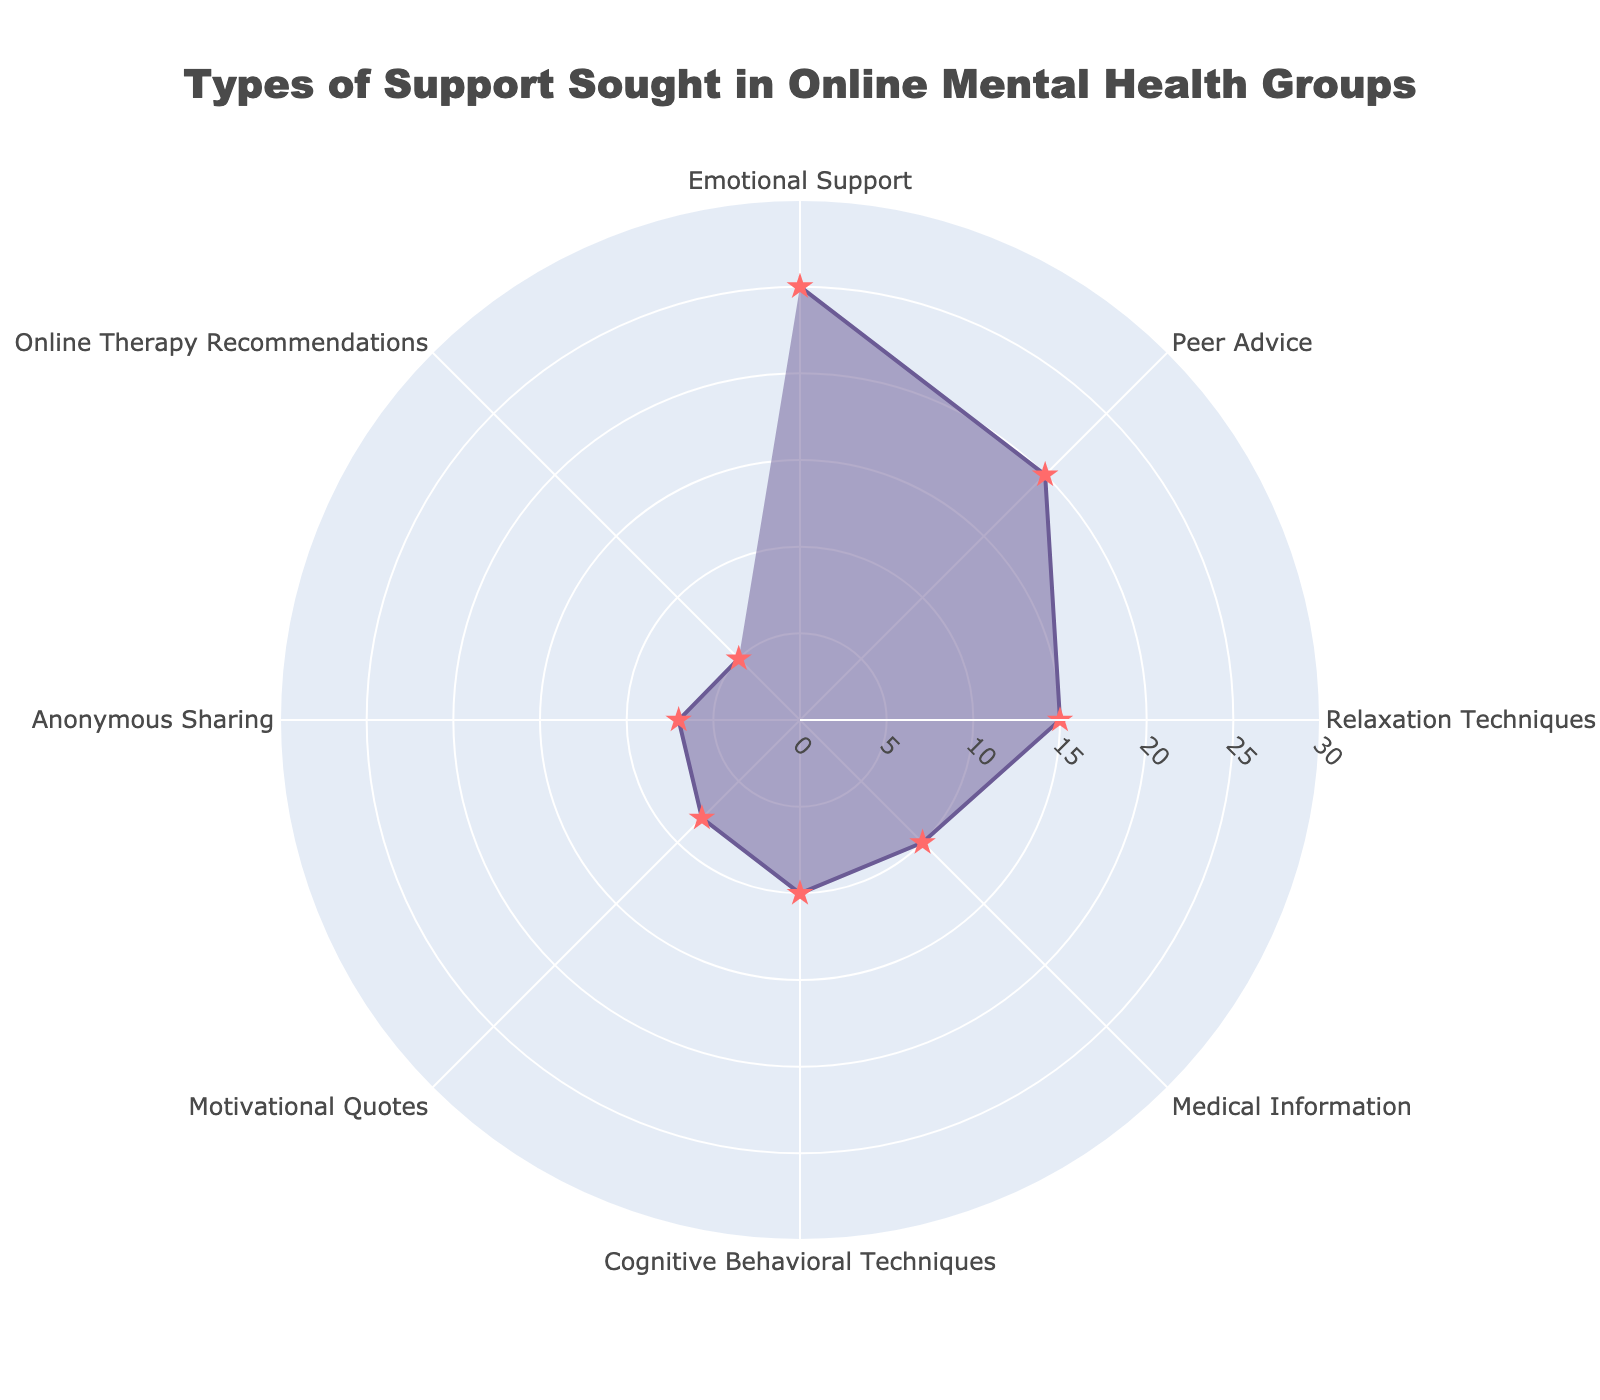what is the title of the chart? The title is located at the top of the figure. It summarises the main theme of the chart. By looking at the top, you can easily identify the text in a larger font size and different color (grayish) that reads "Types of Support Sought in Online Mental Health Groups".
Answer: Types of Support Sought in Online Mental Health Groups how many different types of support are depicted in the chart? By counting the distinct labels around the perimeter of the chart, you can identify the number of different categories represented. Each category represents a type of support sought in online mental health groups.
Answer: 8 what percentage of people sought emotional support? By referring to the corresponding radial distance of the "Emotional Support" category, you can find the percentage. The radial axis value under this category shows 25.
Answer: 25 which category has the least percentage of support sought? By comparing the radial lengths of all categories, the category with the shortest radial line represents the least percentage. "Online Therapy Recommendations" has the shortest radial line.
Answer: Online Therapy Recommendations what is the sum of the percentages of the three most sought types of support? Firstly, identify the three categories with the highest percentages: Emotional Support (25), Peer Advice (20), and Relaxation Techniques (15). Then, sum these values: 25 + 20 + 15 = 60.
Answer: 60 how does the percentage of peer advice compare to that of anonymous sharing? Refer to the radial lengths of "Peer Advice" and "Anonymous Sharing." "Peer Advice" has a radial length of 20, whereas "Anonymous Sharing" has a value of 7. Therefore, "Peer Advice" is significantly higher.
Answer: Peer Advice is higher what is the average percentage value for cognitive behavioral techniques and motivational quotes? Find the radial values for "Cognitive Behavioral Techniques" (10) and "Motivational Quotes" (8). Sum them up (10 + 8) and divide by 2 to find the average: 18/2 = 9.
Answer: 9 which types of support are sought by more than 10% of people? Identify all categories with radial values greater than 10. These are "Emotional Support" (25), "Peer Advice" (20), and "Relaxation Techniques" (15).
Answer: Emotional Support, Peer Advice, Relaxation Techniques how much more is the percentage of emotional support compared to medical information? Find the radial values for "Emotional Support" (25) and "Medical Information" (10), then subtract the smaller value from the larger: 25 - 10 = 15.
Answer: 15 in what range do the percentages of different types of support fall? Examine the radial axis to determine the lowest and highest percentage values. The lowest percentage value is 5 (Online Therapy Recommendations) and the highest is 25 (Emotional Support). So the range is from 5% to 25%.
Answer: 5% to 25% 